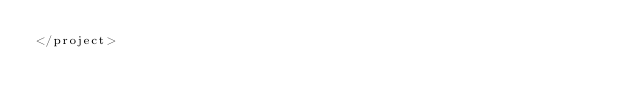Convert code to text. <code><loc_0><loc_0><loc_500><loc_500><_XML_></project></code> 